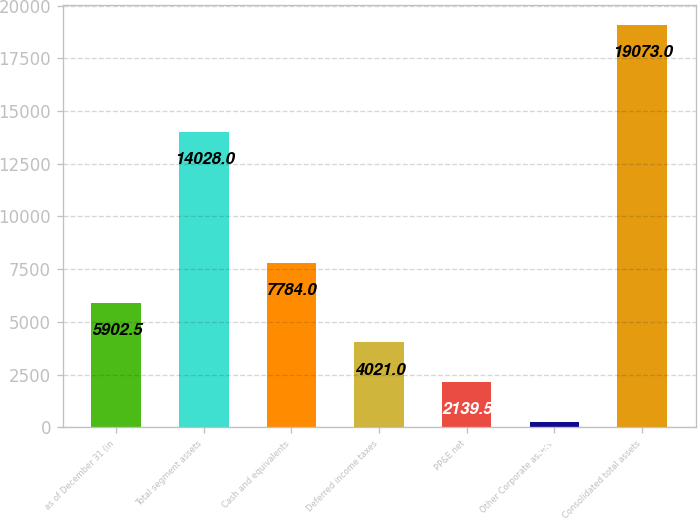<chart> <loc_0><loc_0><loc_500><loc_500><bar_chart><fcel>as of December 31 (in<fcel>Total segment assets<fcel>Cash and equivalents<fcel>Deferred income taxes<fcel>PP&E net<fcel>Other Corporate assets<fcel>Consolidated total assets<nl><fcel>5902.5<fcel>14028<fcel>7784<fcel>4021<fcel>2139.5<fcel>258<fcel>19073<nl></chart> 